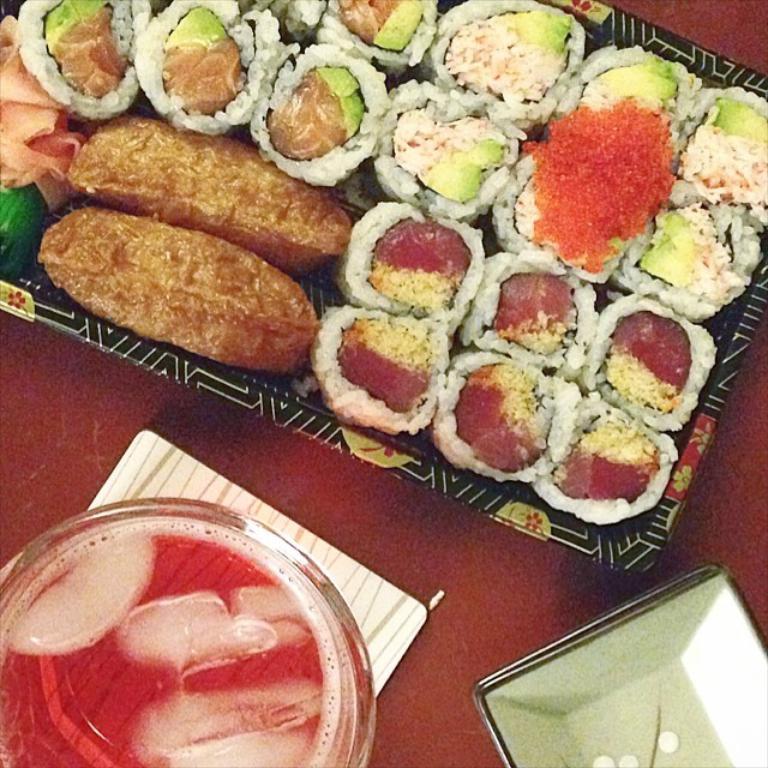Please provide a concise description of this image. In this picture we can see a bowl, a plate and a tray, we can see some food present in this tray, it looks like a table at the bottom. 